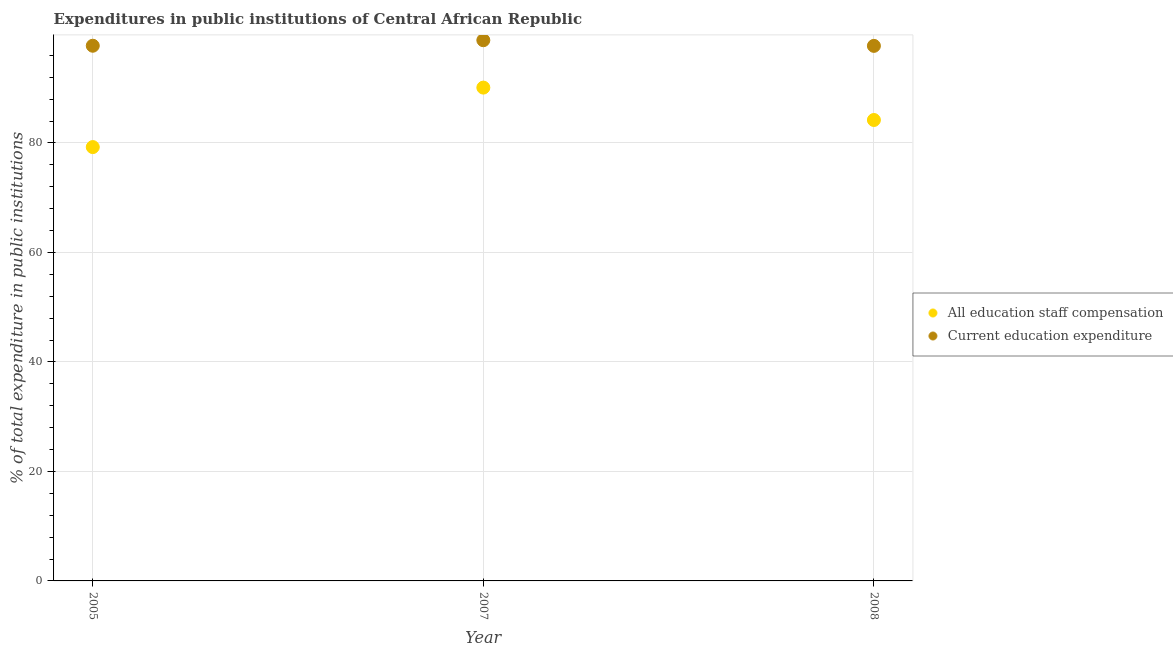What is the expenditure in staff compensation in 2008?
Provide a succinct answer. 84.19. Across all years, what is the maximum expenditure in staff compensation?
Your answer should be very brief. 90.11. Across all years, what is the minimum expenditure in education?
Give a very brief answer. 97.73. In which year was the expenditure in staff compensation minimum?
Your response must be concise. 2005. What is the total expenditure in staff compensation in the graph?
Keep it short and to the point. 253.54. What is the difference between the expenditure in staff compensation in 2005 and that in 2008?
Offer a terse response. -4.95. What is the difference between the expenditure in staff compensation in 2007 and the expenditure in education in 2008?
Your answer should be compact. -7.62. What is the average expenditure in staff compensation per year?
Provide a short and direct response. 84.51. In the year 2005, what is the difference between the expenditure in staff compensation and expenditure in education?
Offer a terse response. -18.51. What is the ratio of the expenditure in staff compensation in 2005 to that in 2007?
Your response must be concise. 0.88. Is the expenditure in education in 2007 less than that in 2008?
Your response must be concise. No. What is the difference between the highest and the second highest expenditure in education?
Give a very brief answer. 1.01. What is the difference between the highest and the lowest expenditure in staff compensation?
Offer a terse response. 10.86. In how many years, is the expenditure in staff compensation greater than the average expenditure in staff compensation taken over all years?
Give a very brief answer. 1. Is the sum of the expenditure in education in 2005 and 2008 greater than the maximum expenditure in staff compensation across all years?
Offer a terse response. Yes. Does the expenditure in staff compensation monotonically increase over the years?
Keep it short and to the point. No. Is the expenditure in staff compensation strictly less than the expenditure in education over the years?
Your answer should be compact. Yes. How many years are there in the graph?
Give a very brief answer. 3. Does the graph contain grids?
Provide a succinct answer. Yes. How many legend labels are there?
Make the answer very short. 2. How are the legend labels stacked?
Your response must be concise. Vertical. What is the title of the graph?
Provide a short and direct response. Expenditures in public institutions of Central African Republic. Does "Taxes" appear as one of the legend labels in the graph?
Keep it short and to the point. No. What is the label or title of the X-axis?
Provide a short and direct response. Year. What is the label or title of the Y-axis?
Provide a succinct answer. % of total expenditure in public institutions. What is the % of total expenditure in public institutions in All education staff compensation in 2005?
Ensure brevity in your answer.  79.24. What is the % of total expenditure in public institutions in Current education expenditure in 2005?
Offer a very short reply. 97.75. What is the % of total expenditure in public institutions of All education staff compensation in 2007?
Your response must be concise. 90.11. What is the % of total expenditure in public institutions in Current education expenditure in 2007?
Give a very brief answer. 98.76. What is the % of total expenditure in public institutions in All education staff compensation in 2008?
Ensure brevity in your answer.  84.19. What is the % of total expenditure in public institutions in Current education expenditure in 2008?
Offer a terse response. 97.73. Across all years, what is the maximum % of total expenditure in public institutions of All education staff compensation?
Provide a short and direct response. 90.11. Across all years, what is the maximum % of total expenditure in public institutions in Current education expenditure?
Offer a very short reply. 98.76. Across all years, what is the minimum % of total expenditure in public institutions in All education staff compensation?
Offer a terse response. 79.24. Across all years, what is the minimum % of total expenditure in public institutions of Current education expenditure?
Provide a succinct answer. 97.73. What is the total % of total expenditure in public institutions in All education staff compensation in the graph?
Give a very brief answer. 253.54. What is the total % of total expenditure in public institutions in Current education expenditure in the graph?
Provide a succinct answer. 294.24. What is the difference between the % of total expenditure in public institutions in All education staff compensation in 2005 and that in 2007?
Give a very brief answer. -10.86. What is the difference between the % of total expenditure in public institutions in Current education expenditure in 2005 and that in 2007?
Ensure brevity in your answer.  -1.01. What is the difference between the % of total expenditure in public institutions in All education staff compensation in 2005 and that in 2008?
Your answer should be compact. -4.95. What is the difference between the % of total expenditure in public institutions of Current education expenditure in 2005 and that in 2008?
Your response must be concise. 0.02. What is the difference between the % of total expenditure in public institutions in All education staff compensation in 2007 and that in 2008?
Your answer should be very brief. 5.92. What is the difference between the % of total expenditure in public institutions in Current education expenditure in 2007 and that in 2008?
Offer a terse response. 1.03. What is the difference between the % of total expenditure in public institutions in All education staff compensation in 2005 and the % of total expenditure in public institutions in Current education expenditure in 2007?
Your answer should be compact. -19.52. What is the difference between the % of total expenditure in public institutions in All education staff compensation in 2005 and the % of total expenditure in public institutions in Current education expenditure in 2008?
Offer a terse response. -18.49. What is the difference between the % of total expenditure in public institutions in All education staff compensation in 2007 and the % of total expenditure in public institutions in Current education expenditure in 2008?
Give a very brief answer. -7.62. What is the average % of total expenditure in public institutions of All education staff compensation per year?
Offer a very short reply. 84.51. What is the average % of total expenditure in public institutions in Current education expenditure per year?
Your response must be concise. 98.08. In the year 2005, what is the difference between the % of total expenditure in public institutions of All education staff compensation and % of total expenditure in public institutions of Current education expenditure?
Your answer should be compact. -18.51. In the year 2007, what is the difference between the % of total expenditure in public institutions in All education staff compensation and % of total expenditure in public institutions in Current education expenditure?
Your answer should be compact. -8.65. In the year 2008, what is the difference between the % of total expenditure in public institutions in All education staff compensation and % of total expenditure in public institutions in Current education expenditure?
Provide a succinct answer. -13.54. What is the ratio of the % of total expenditure in public institutions in All education staff compensation in 2005 to that in 2007?
Give a very brief answer. 0.88. What is the ratio of the % of total expenditure in public institutions in All education staff compensation in 2005 to that in 2008?
Your answer should be very brief. 0.94. What is the ratio of the % of total expenditure in public institutions in Current education expenditure in 2005 to that in 2008?
Make the answer very short. 1. What is the ratio of the % of total expenditure in public institutions of All education staff compensation in 2007 to that in 2008?
Offer a terse response. 1.07. What is the ratio of the % of total expenditure in public institutions in Current education expenditure in 2007 to that in 2008?
Your answer should be compact. 1.01. What is the difference between the highest and the second highest % of total expenditure in public institutions of All education staff compensation?
Provide a short and direct response. 5.92. What is the difference between the highest and the second highest % of total expenditure in public institutions of Current education expenditure?
Keep it short and to the point. 1.01. What is the difference between the highest and the lowest % of total expenditure in public institutions of All education staff compensation?
Offer a terse response. 10.86. What is the difference between the highest and the lowest % of total expenditure in public institutions in Current education expenditure?
Make the answer very short. 1.03. 